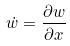Convert formula to latex. <formula><loc_0><loc_0><loc_500><loc_500>\dot { w } = \frac { \partial w } { \partial x }</formula> 